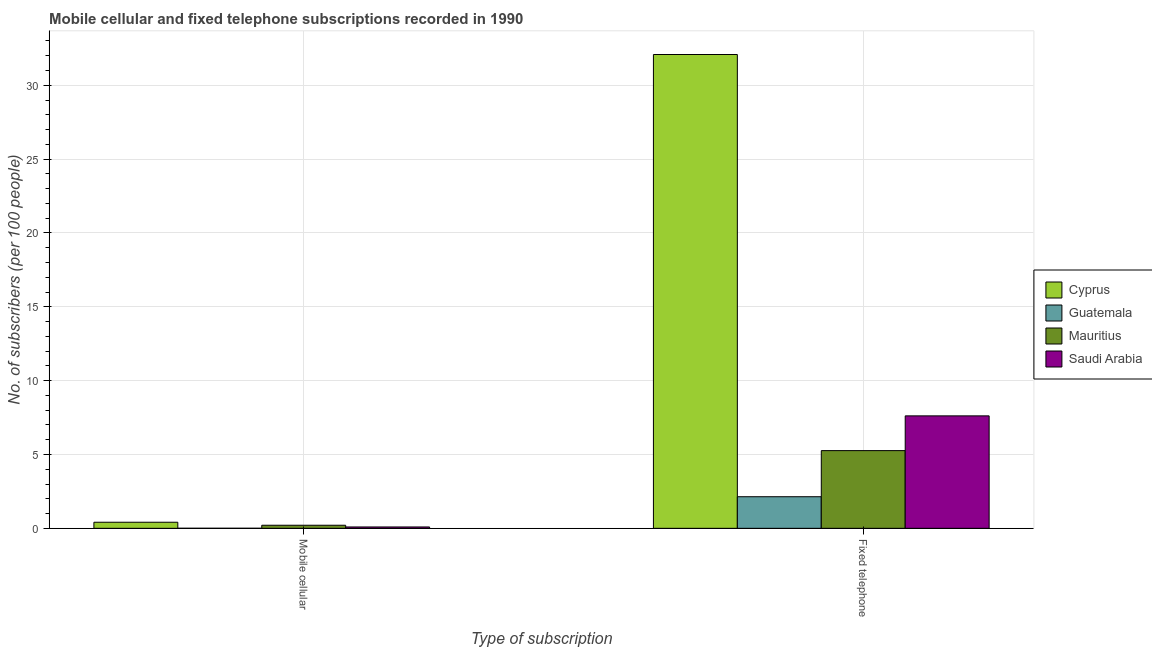How many different coloured bars are there?
Offer a very short reply. 4. Are the number of bars per tick equal to the number of legend labels?
Your response must be concise. Yes. How many bars are there on the 2nd tick from the left?
Make the answer very short. 4. What is the label of the 2nd group of bars from the left?
Keep it short and to the point. Fixed telephone. What is the number of mobile cellular subscribers in Cyprus?
Your answer should be compact. 0.41. Across all countries, what is the maximum number of fixed telephone subscribers?
Make the answer very short. 32.08. Across all countries, what is the minimum number of fixed telephone subscribers?
Offer a very short reply. 2.14. In which country was the number of fixed telephone subscribers maximum?
Make the answer very short. Cyprus. In which country was the number of fixed telephone subscribers minimum?
Your response must be concise. Guatemala. What is the total number of fixed telephone subscribers in the graph?
Offer a terse response. 47.1. What is the difference between the number of mobile cellular subscribers in Mauritius and that in Saudi Arabia?
Provide a short and direct response. 0.12. What is the difference between the number of mobile cellular subscribers in Saudi Arabia and the number of fixed telephone subscribers in Mauritius?
Your answer should be compact. -5.17. What is the average number of fixed telephone subscribers per country?
Provide a short and direct response. 11.77. What is the difference between the number of fixed telephone subscribers and number of mobile cellular subscribers in Guatemala?
Offer a terse response. 2.14. What is the ratio of the number of fixed telephone subscribers in Guatemala to that in Saudi Arabia?
Offer a very short reply. 0.28. Is the number of fixed telephone subscribers in Mauritius less than that in Saudi Arabia?
Your answer should be compact. Yes. What does the 1st bar from the left in Fixed telephone represents?
Ensure brevity in your answer.  Cyprus. What does the 1st bar from the right in Mobile cellular represents?
Your response must be concise. Saudi Arabia. How many bars are there?
Keep it short and to the point. 8. Are all the bars in the graph horizontal?
Ensure brevity in your answer.  No. How many countries are there in the graph?
Offer a very short reply. 4. How many legend labels are there?
Give a very brief answer. 4. How are the legend labels stacked?
Ensure brevity in your answer.  Vertical. What is the title of the graph?
Provide a succinct answer. Mobile cellular and fixed telephone subscriptions recorded in 1990. Does "China" appear as one of the legend labels in the graph?
Ensure brevity in your answer.  No. What is the label or title of the X-axis?
Keep it short and to the point. Type of subscription. What is the label or title of the Y-axis?
Ensure brevity in your answer.  No. of subscribers (per 100 people). What is the No. of subscribers (per 100 people) in Cyprus in Mobile cellular?
Keep it short and to the point. 0.41. What is the No. of subscribers (per 100 people) of Guatemala in Mobile cellular?
Your answer should be very brief. 0. What is the No. of subscribers (per 100 people) of Mauritius in Mobile cellular?
Keep it short and to the point. 0.21. What is the No. of subscribers (per 100 people) in Saudi Arabia in Mobile cellular?
Your answer should be very brief. 0.09. What is the No. of subscribers (per 100 people) of Cyprus in Fixed telephone?
Make the answer very short. 32.08. What is the No. of subscribers (per 100 people) in Guatemala in Fixed telephone?
Your answer should be compact. 2.14. What is the No. of subscribers (per 100 people) in Mauritius in Fixed telephone?
Your answer should be very brief. 5.26. What is the No. of subscribers (per 100 people) in Saudi Arabia in Fixed telephone?
Provide a short and direct response. 7.61. Across all Type of subscription, what is the maximum No. of subscribers (per 100 people) in Cyprus?
Give a very brief answer. 32.08. Across all Type of subscription, what is the maximum No. of subscribers (per 100 people) in Guatemala?
Your response must be concise. 2.14. Across all Type of subscription, what is the maximum No. of subscribers (per 100 people) of Mauritius?
Offer a terse response. 5.26. Across all Type of subscription, what is the maximum No. of subscribers (per 100 people) of Saudi Arabia?
Provide a succinct answer. 7.61. Across all Type of subscription, what is the minimum No. of subscribers (per 100 people) in Cyprus?
Keep it short and to the point. 0.41. Across all Type of subscription, what is the minimum No. of subscribers (per 100 people) of Guatemala?
Your answer should be compact. 0. Across all Type of subscription, what is the minimum No. of subscribers (per 100 people) of Mauritius?
Make the answer very short. 0.21. Across all Type of subscription, what is the minimum No. of subscribers (per 100 people) in Saudi Arabia?
Offer a terse response. 0.09. What is the total No. of subscribers (per 100 people) in Cyprus in the graph?
Your answer should be compact. 32.49. What is the total No. of subscribers (per 100 people) of Guatemala in the graph?
Your response must be concise. 2.14. What is the total No. of subscribers (per 100 people) of Mauritius in the graph?
Your answer should be compact. 5.47. What is the total No. of subscribers (per 100 people) of Saudi Arabia in the graph?
Offer a very short reply. 7.71. What is the difference between the No. of subscribers (per 100 people) in Cyprus in Mobile cellular and that in Fixed telephone?
Your answer should be very brief. -31.67. What is the difference between the No. of subscribers (per 100 people) in Guatemala in Mobile cellular and that in Fixed telephone?
Provide a short and direct response. -2.14. What is the difference between the No. of subscribers (per 100 people) of Mauritius in Mobile cellular and that in Fixed telephone?
Your answer should be very brief. -5.05. What is the difference between the No. of subscribers (per 100 people) in Saudi Arabia in Mobile cellular and that in Fixed telephone?
Provide a succinct answer. -7.52. What is the difference between the No. of subscribers (per 100 people) in Cyprus in Mobile cellular and the No. of subscribers (per 100 people) in Guatemala in Fixed telephone?
Offer a terse response. -1.73. What is the difference between the No. of subscribers (per 100 people) of Cyprus in Mobile cellular and the No. of subscribers (per 100 people) of Mauritius in Fixed telephone?
Provide a succinct answer. -4.85. What is the difference between the No. of subscribers (per 100 people) in Cyprus in Mobile cellular and the No. of subscribers (per 100 people) in Saudi Arabia in Fixed telephone?
Your answer should be compact. -7.2. What is the difference between the No. of subscribers (per 100 people) in Guatemala in Mobile cellular and the No. of subscribers (per 100 people) in Mauritius in Fixed telephone?
Provide a short and direct response. -5.26. What is the difference between the No. of subscribers (per 100 people) of Guatemala in Mobile cellular and the No. of subscribers (per 100 people) of Saudi Arabia in Fixed telephone?
Provide a short and direct response. -7.61. What is the difference between the No. of subscribers (per 100 people) in Mauritius in Mobile cellular and the No. of subscribers (per 100 people) in Saudi Arabia in Fixed telephone?
Provide a succinct answer. -7.41. What is the average No. of subscribers (per 100 people) in Cyprus per Type of subscription?
Offer a very short reply. 16.25. What is the average No. of subscribers (per 100 people) of Guatemala per Type of subscription?
Keep it short and to the point. 1.07. What is the average No. of subscribers (per 100 people) of Mauritius per Type of subscription?
Give a very brief answer. 2.73. What is the average No. of subscribers (per 100 people) of Saudi Arabia per Type of subscription?
Your answer should be compact. 3.85. What is the difference between the No. of subscribers (per 100 people) in Cyprus and No. of subscribers (per 100 people) in Guatemala in Mobile cellular?
Give a very brief answer. 0.41. What is the difference between the No. of subscribers (per 100 people) in Cyprus and No. of subscribers (per 100 people) in Mauritius in Mobile cellular?
Offer a very short reply. 0.2. What is the difference between the No. of subscribers (per 100 people) of Cyprus and No. of subscribers (per 100 people) of Saudi Arabia in Mobile cellular?
Ensure brevity in your answer.  0.32. What is the difference between the No. of subscribers (per 100 people) of Guatemala and No. of subscribers (per 100 people) of Mauritius in Mobile cellular?
Provide a short and direct response. -0.21. What is the difference between the No. of subscribers (per 100 people) of Guatemala and No. of subscribers (per 100 people) of Saudi Arabia in Mobile cellular?
Make the answer very short. -0.09. What is the difference between the No. of subscribers (per 100 people) in Mauritius and No. of subscribers (per 100 people) in Saudi Arabia in Mobile cellular?
Provide a short and direct response. 0.12. What is the difference between the No. of subscribers (per 100 people) in Cyprus and No. of subscribers (per 100 people) in Guatemala in Fixed telephone?
Your answer should be compact. 29.94. What is the difference between the No. of subscribers (per 100 people) in Cyprus and No. of subscribers (per 100 people) in Mauritius in Fixed telephone?
Ensure brevity in your answer.  26.82. What is the difference between the No. of subscribers (per 100 people) in Cyprus and No. of subscribers (per 100 people) in Saudi Arabia in Fixed telephone?
Make the answer very short. 24.47. What is the difference between the No. of subscribers (per 100 people) of Guatemala and No. of subscribers (per 100 people) of Mauritius in Fixed telephone?
Provide a succinct answer. -3.12. What is the difference between the No. of subscribers (per 100 people) in Guatemala and No. of subscribers (per 100 people) in Saudi Arabia in Fixed telephone?
Your answer should be compact. -5.47. What is the difference between the No. of subscribers (per 100 people) in Mauritius and No. of subscribers (per 100 people) in Saudi Arabia in Fixed telephone?
Your response must be concise. -2.35. What is the ratio of the No. of subscribers (per 100 people) in Cyprus in Mobile cellular to that in Fixed telephone?
Your answer should be very brief. 0.01. What is the ratio of the No. of subscribers (per 100 people) of Guatemala in Mobile cellular to that in Fixed telephone?
Your response must be concise. 0. What is the ratio of the No. of subscribers (per 100 people) in Mauritius in Mobile cellular to that in Fixed telephone?
Provide a succinct answer. 0.04. What is the ratio of the No. of subscribers (per 100 people) of Saudi Arabia in Mobile cellular to that in Fixed telephone?
Provide a succinct answer. 0.01. What is the difference between the highest and the second highest No. of subscribers (per 100 people) in Cyprus?
Your response must be concise. 31.67. What is the difference between the highest and the second highest No. of subscribers (per 100 people) in Guatemala?
Your answer should be very brief. 2.14. What is the difference between the highest and the second highest No. of subscribers (per 100 people) of Mauritius?
Your answer should be compact. 5.05. What is the difference between the highest and the second highest No. of subscribers (per 100 people) of Saudi Arabia?
Provide a short and direct response. 7.52. What is the difference between the highest and the lowest No. of subscribers (per 100 people) of Cyprus?
Ensure brevity in your answer.  31.67. What is the difference between the highest and the lowest No. of subscribers (per 100 people) in Guatemala?
Your answer should be compact. 2.14. What is the difference between the highest and the lowest No. of subscribers (per 100 people) of Mauritius?
Offer a very short reply. 5.05. What is the difference between the highest and the lowest No. of subscribers (per 100 people) in Saudi Arabia?
Your response must be concise. 7.52. 